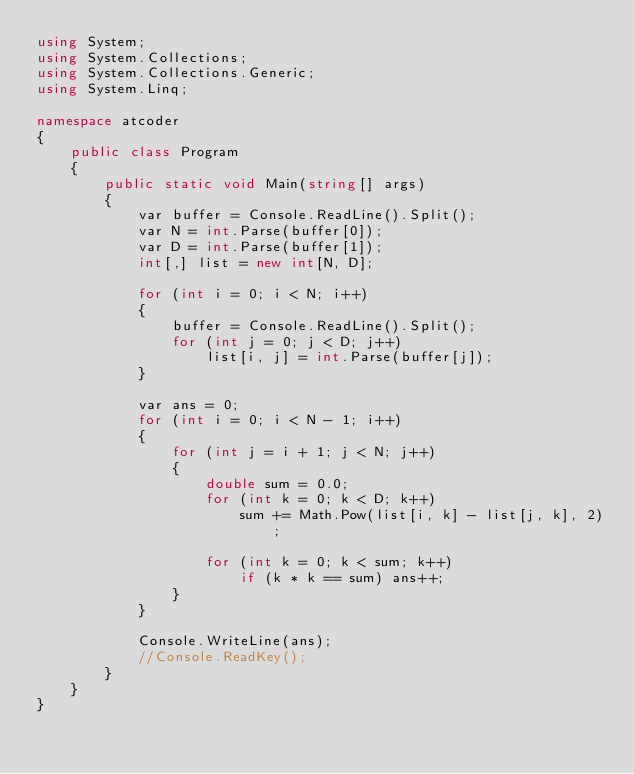Convert code to text. <code><loc_0><loc_0><loc_500><loc_500><_C#_>using System;
using System.Collections;
using System.Collections.Generic;
using System.Linq;

namespace atcoder
{
    public class Program
    {
        public static void Main(string[] args)
        {
            var buffer = Console.ReadLine().Split();
            var N = int.Parse(buffer[0]);
            var D = int.Parse(buffer[1]);
            int[,] list = new int[N, D];

            for (int i = 0; i < N; i++)
            {
                buffer = Console.ReadLine().Split();
                for (int j = 0; j < D; j++)
                    list[i, j] = int.Parse(buffer[j]);
            }

            var ans = 0;
            for (int i = 0; i < N - 1; i++)
            {
                for (int j = i + 1; j < N; j++)
                {
                    double sum = 0.0;
                    for (int k = 0; k < D; k++)
                        sum += Math.Pow(list[i, k] - list[j, k], 2);

                    for (int k = 0; k < sum; k++)
                        if (k * k == sum) ans++;
                }
            }

            Console.WriteLine(ans);
            //Console.ReadKey();
        }
    }
}
</code> 